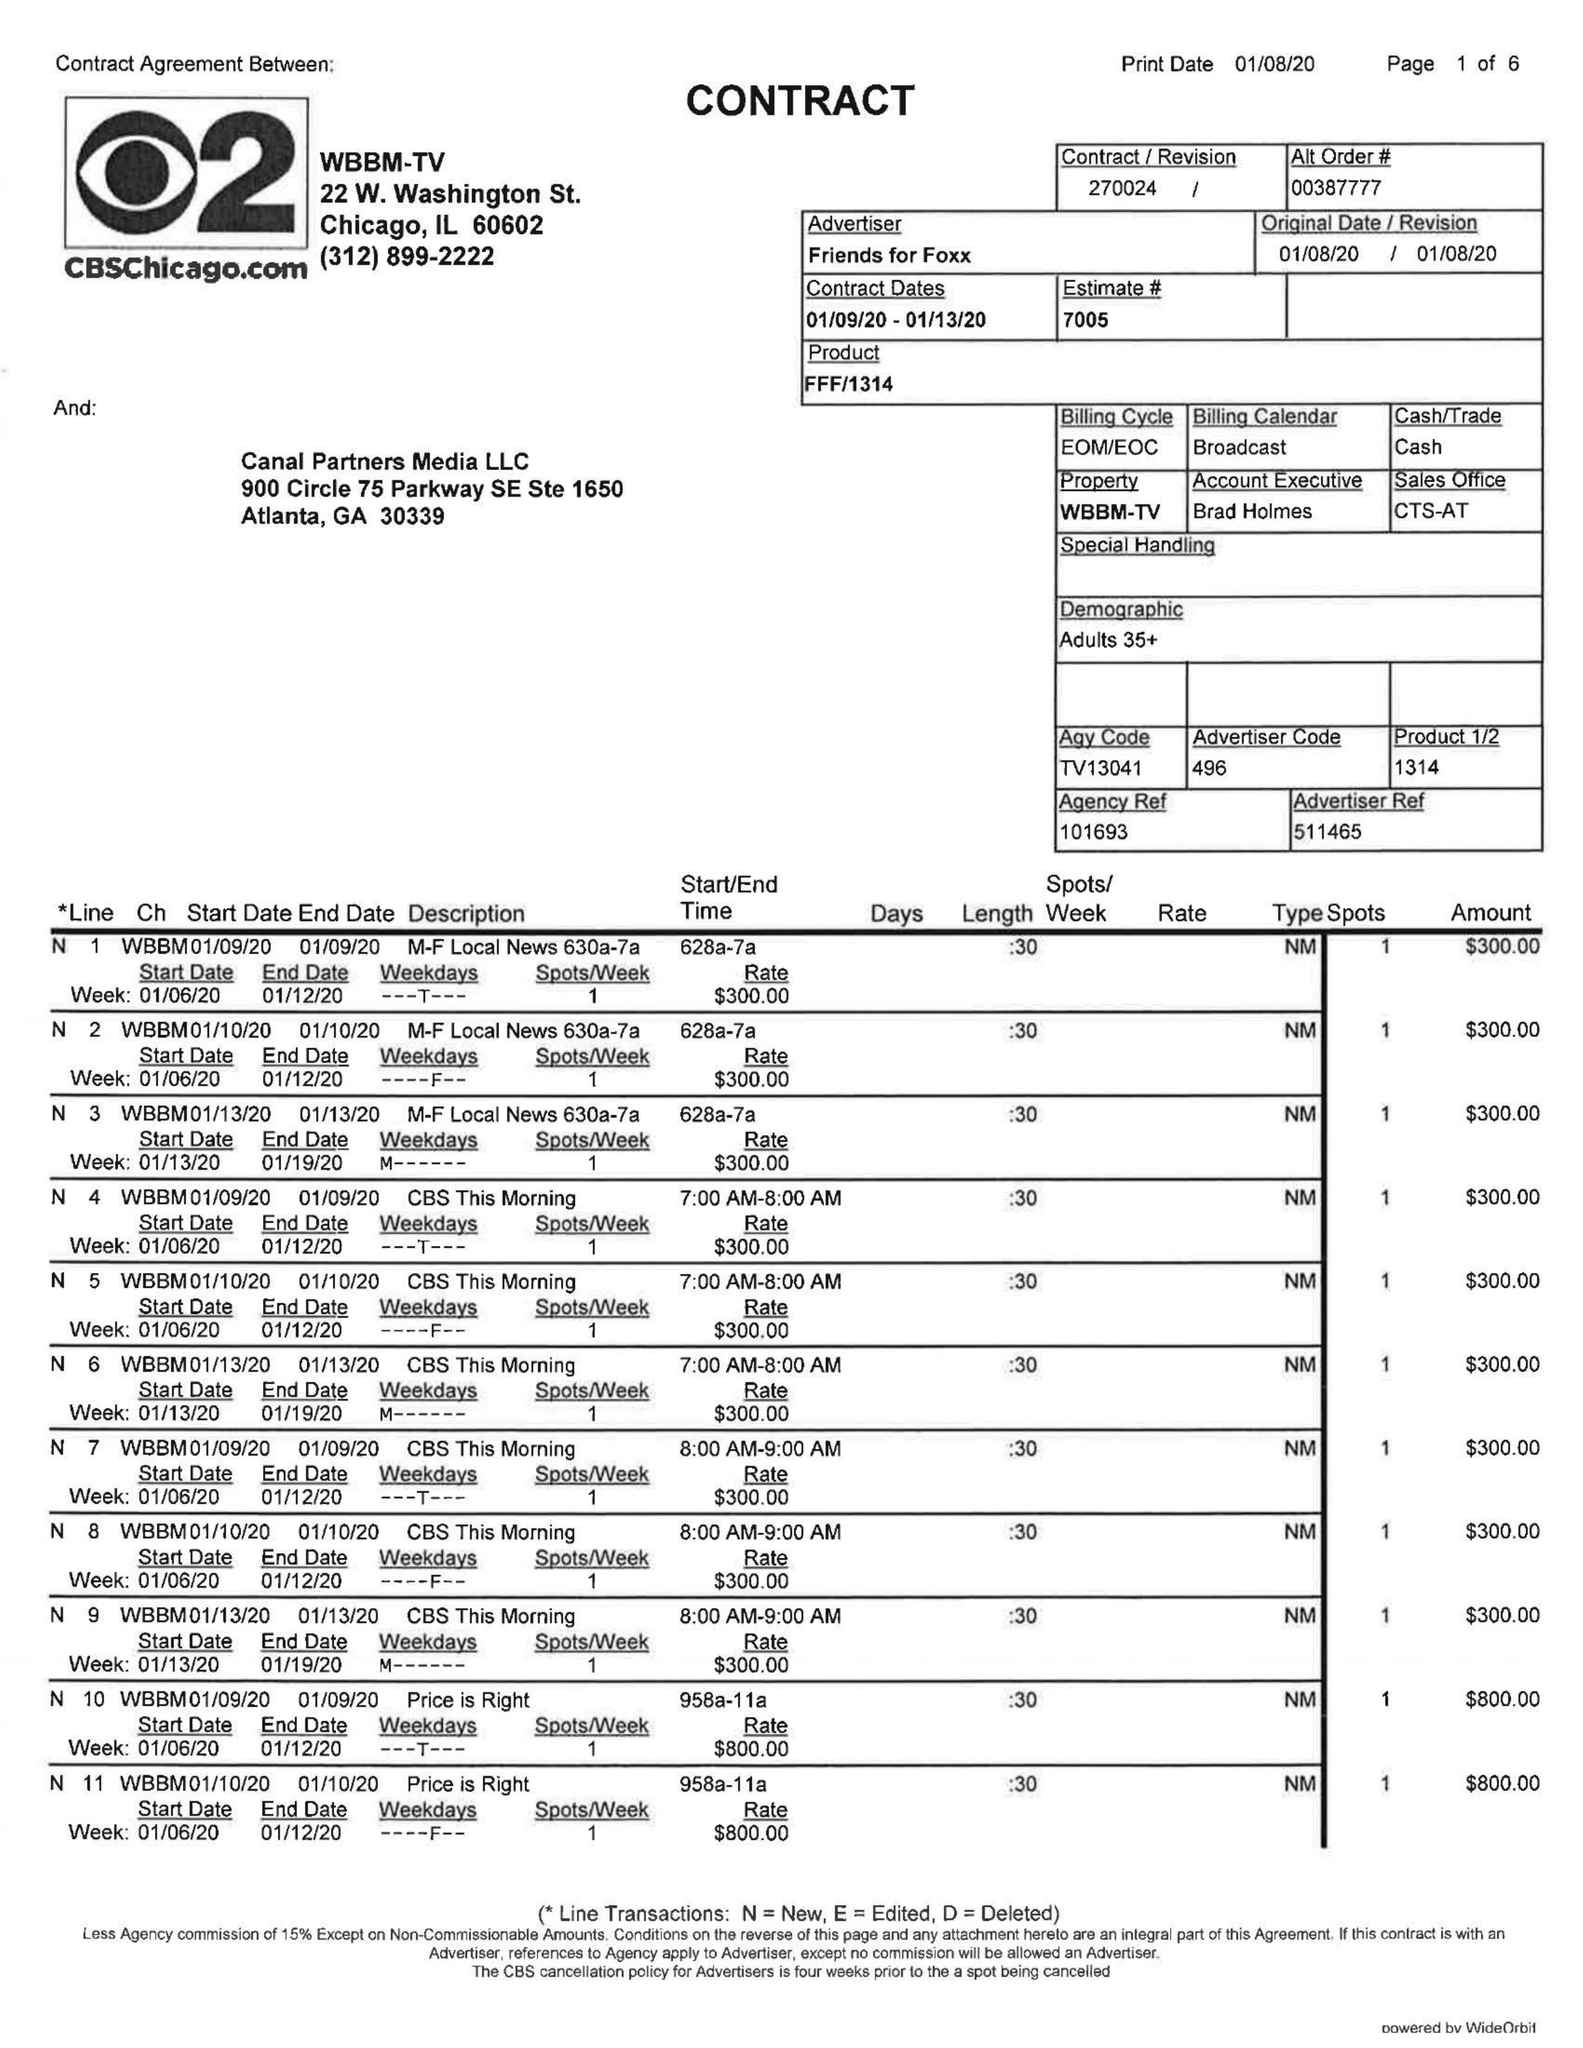What is the value for the gross_amount?
Answer the question using a single word or phrase. 34150.00 